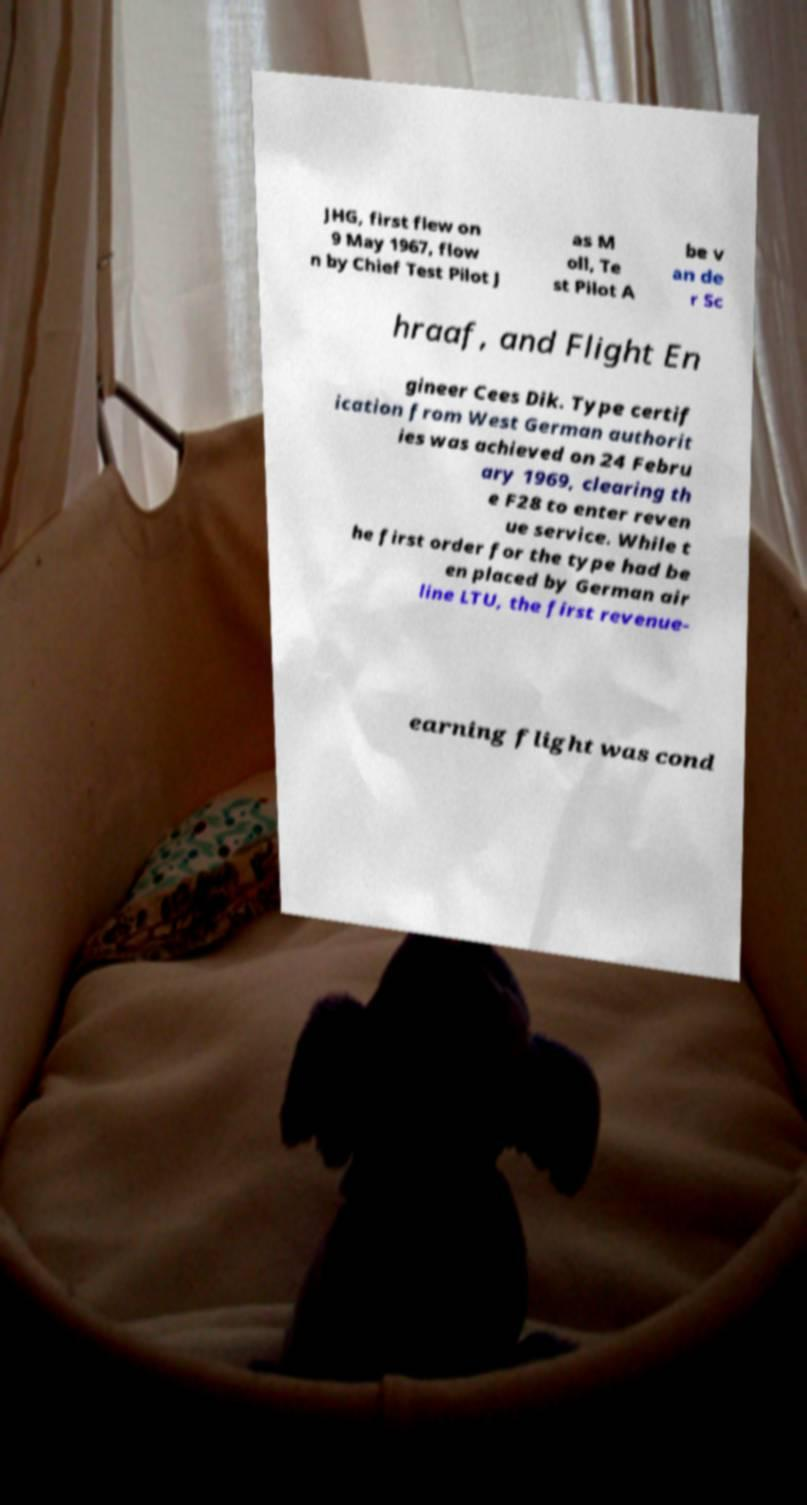For documentation purposes, I need the text within this image transcribed. Could you provide that? JHG, first flew on 9 May 1967, flow n by Chief Test Pilot J as M oll, Te st Pilot A be v an de r Sc hraaf, and Flight En gineer Cees Dik. Type certif ication from West German authorit ies was achieved on 24 Febru ary 1969, clearing th e F28 to enter reven ue service. While t he first order for the type had be en placed by German air line LTU, the first revenue- earning flight was cond 